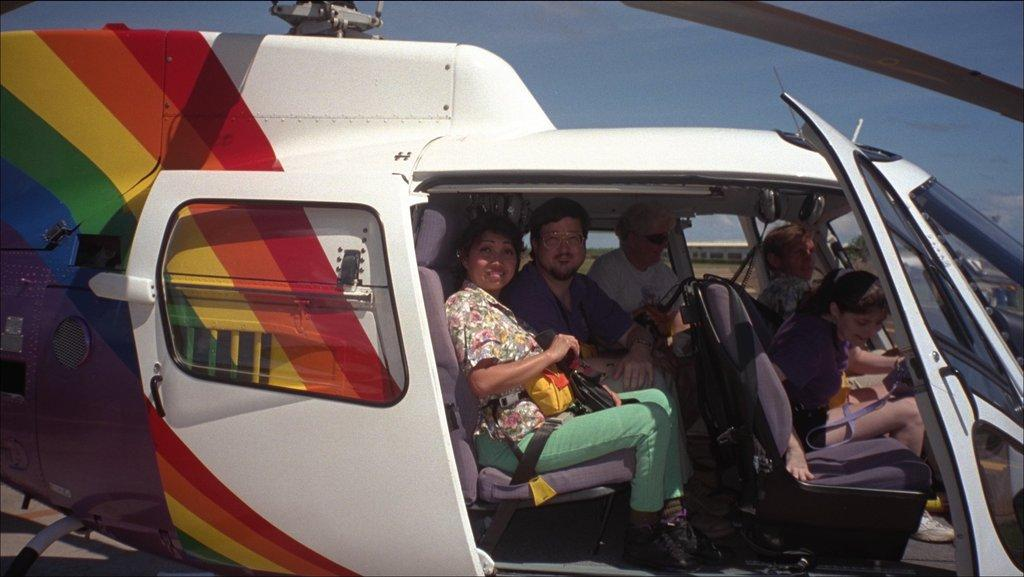What is the main subject of the image? The main subject of the image is an aeroplane. Are there any passengers inside the aeroplane? Yes, there are people sitting inside the aeroplane. How would you describe the appearance of the aeroplane? The aeroplane is colorful. What colors can be seen in the sky in the image? The sky is blue and white in color. What type of stone is being used to build the town in the image? There is no town present in the image; it features an aeroplane and people sitting inside it. Can you tell me how many gravestones are visible in the cemetery in the image? There is no cemetery present in the image; it features an aeroplane and people sitting inside it. 